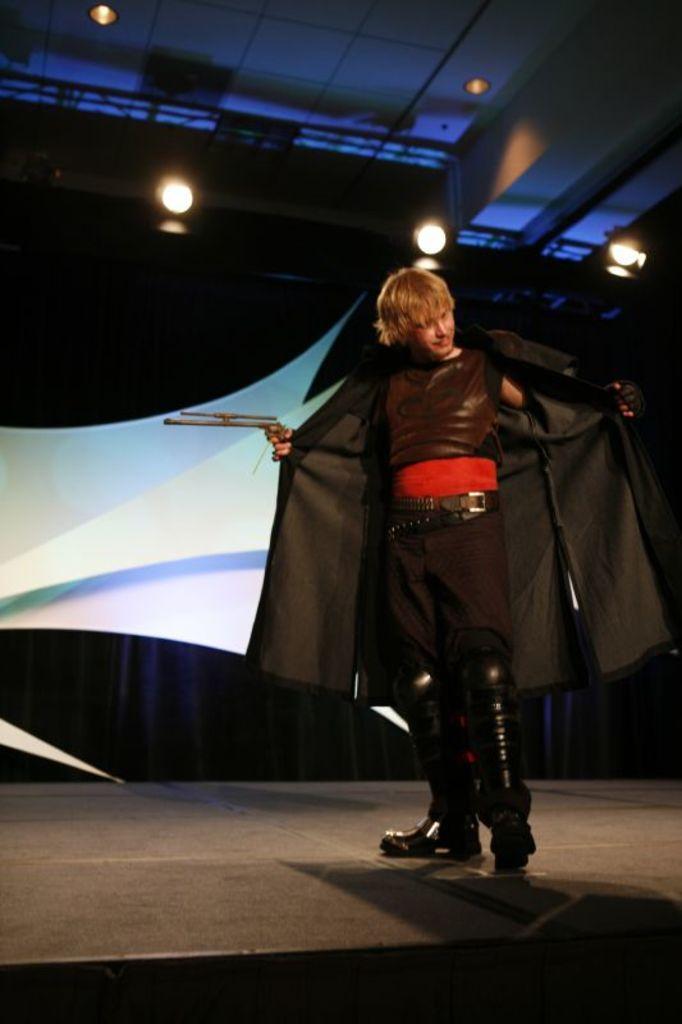Please provide a concise description of this image. As we can see in the image there is a banner, lights and a man wearing black color dress. 